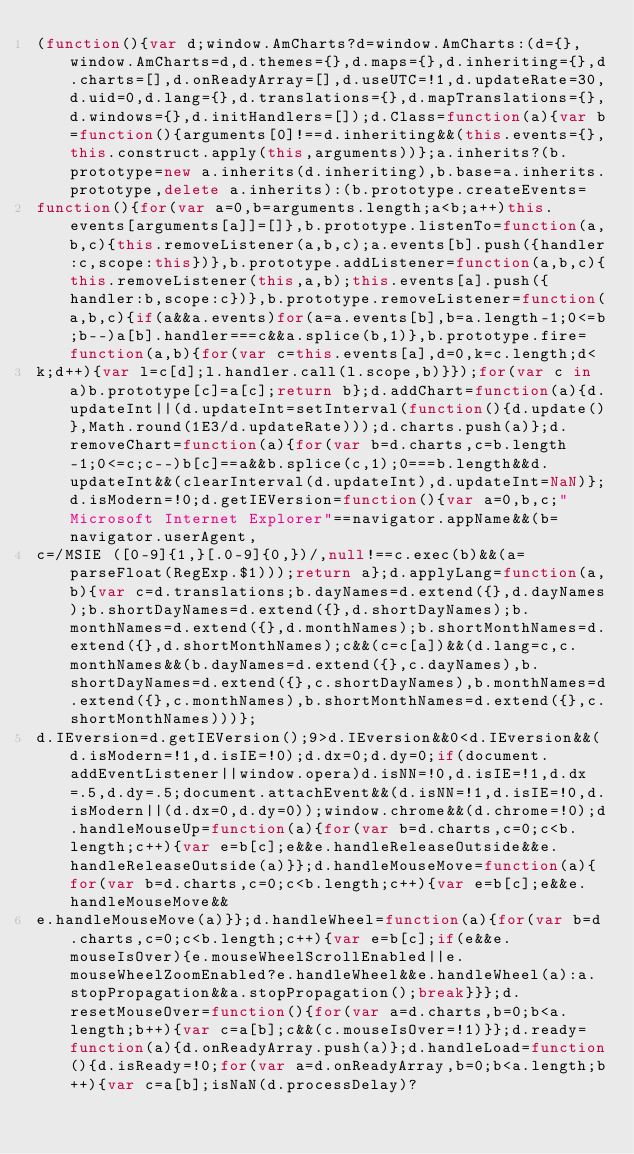<code> <loc_0><loc_0><loc_500><loc_500><_JavaScript_>(function(){var d;window.AmCharts?d=window.AmCharts:(d={},window.AmCharts=d,d.themes={},d.maps={},d.inheriting={},d.charts=[],d.onReadyArray=[],d.useUTC=!1,d.updateRate=30,d.uid=0,d.lang={},d.translations={},d.mapTranslations={},d.windows={},d.initHandlers=[]);d.Class=function(a){var b=function(){arguments[0]!==d.inheriting&&(this.events={},this.construct.apply(this,arguments))};a.inherits?(b.prototype=new a.inherits(d.inheriting),b.base=a.inherits.prototype,delete a.inherits):(b.prototype.createEvents=
function(){for(var a=0,b=arguments.length;a<b;a++)this.events[arguments[a]]=[]},b.prototype.listenTo=function(a,b,c){this.removeListener(a,b,c);a.events[b].push({handler:c,scope:this})},b.prototype.addListener=function(a,b,c){this.removeListener(this,a,b);this.events[a].push({handler:b,scope:c})},b.prototype.removeListener=function(a,b,c){if(a&&a.events)for(a=a.events[b],b=a.length-1;0<=b;b--)a[b].handler===c&&a.splice(b,1)},b.prototype.fire=function(a,b){for(var c=this.events[a],d=0,k=c.length;d<
k;d++){var l=c[d];l.handler.call(l.scope,b)}});for(var c in a)b.prototype[c]=a[c];return b};d.addChart=function(a){d.updateInt||(d.updateInt=setInterval(function(){d.update()},Math.round(1E3/d.updateRate)));d.charts.push(a)};d.removeChart=function(a){for(var b=d.charts,c=b.length-1;0<=c;c--)b[c]==a&&b.splice(c,1);0===b.length&&d.updateInt&&(clearInterval(d.updateInt),d.updateInt=NaN)};d.isModern=!0;d.getIEVersion=function(){var a=0,b,c;"Microsoft Internet Explorer"==navigator.appName&&(b=navigator.userAgent,
c=/MSIE ([0-9]{1,}[.0-9]{0,})/,null!==c.exec(b)&&(a=parseFloat(RegExp.$1)));return a};d.applyLang=function(a,b){var c=d.translations;b.dayNames=d.extend({},d.dayNames);b.shortDayNames=d.extend({},d.shortDayNames);b.monthNames=d.extend({},d.monthNames);b.shortMonthNames=d.extend({},d.shortMonthNames);c&&(c=c[a])&&(d.lang=c,c.monthNames&&(b.dayNames=d.extend({},c.dayNames),b.shortDayNames=d.extend({},c.shortDayNames),b.monthNames=d.extend({},c.monthNames),b.shortMonthNames=d.extend({},c.shortMonthNames)))};
d.IEversion=d.getIEVersion();9>d.IEversion&&0<d.IEversion&&(d.isModern=!1,d.isIE=!0);d.dx=0;d.dy=0;if(document.addEventListener||window.opera)d.isNN=!0,d.isIE=!1,d.dx=.5,d.dy=.5;document.attachEvent&&(d.isNN=!1,d.isIE=!0,d.isModern||(d.dx=0,d.dy=0));window.chrome&&(d.chrome=!0);d.handleMouseUp=function(a){for(var b=d.charts,c=0;c<b.length;c++){var e=b[c];e&&e.handleReleaseOutside&&e.handleReleaseOutside(a)}};d.handleMouseMove=function(a){for(var b=d.charts,c=0;c<b.length;c++){var e=b[c];e&&e.handleMouseMove&&
e.handleMouseMove(a)}};d.handleWheel=function(a){for(var b=d.charts,c=0;c<b.length;c++){var e=b[c];if(e&&e.mouseIsOver){e.mouseWheelScrollEnabled||e.mouseWheelZoomEnabled?e.handleWheel&&e.handleWheel(a):a.stopPropagation&&a.stopPropagation();break}}};d.resetMouseOver=function(){for(var a=d.charts,b=0;b<a.length;b++){var c=a[b];c&&(c.mouseIsOver=!1)}};d.ready=function(a){d.onReadyArray.push(a)};d.handleLoad=function(){d.isReady=!0;for(var a=d.onReadyArray,b=0;b<a.length;b++){var c=a[b];isNaN(d.processDelay)?</code> 